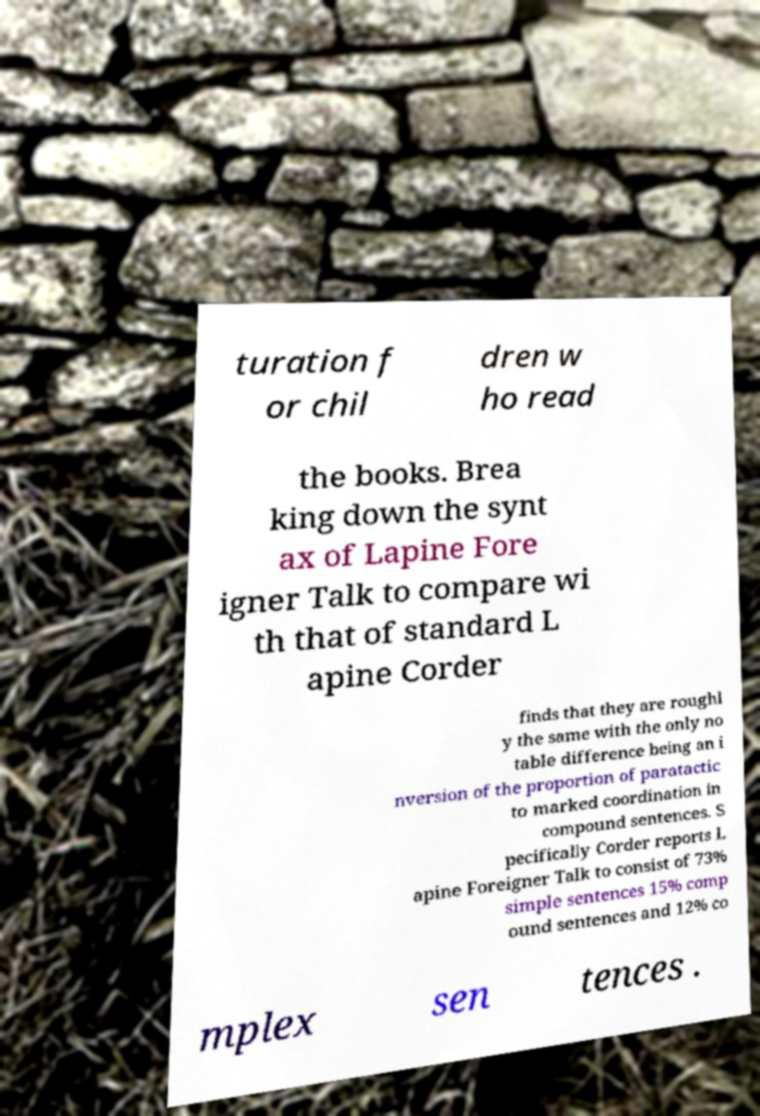For documentation purposes, I need the text within this image transcribed. Could you provide that? turation f or chil dren w ho read the books. Brea king down the synt ax of Lapine Fore igner Talk to compare wi th that of standard L apine Corder finds that they are roughl y the same with the only no table difference being an i nversion of the proportion of paratactic to marked coordination in compound sentences. S pecifically Corder reports L apine Foreigner Talk to consist of 73% simple sentences 15% comp ound sentences and 12% co mplex sen tences . 